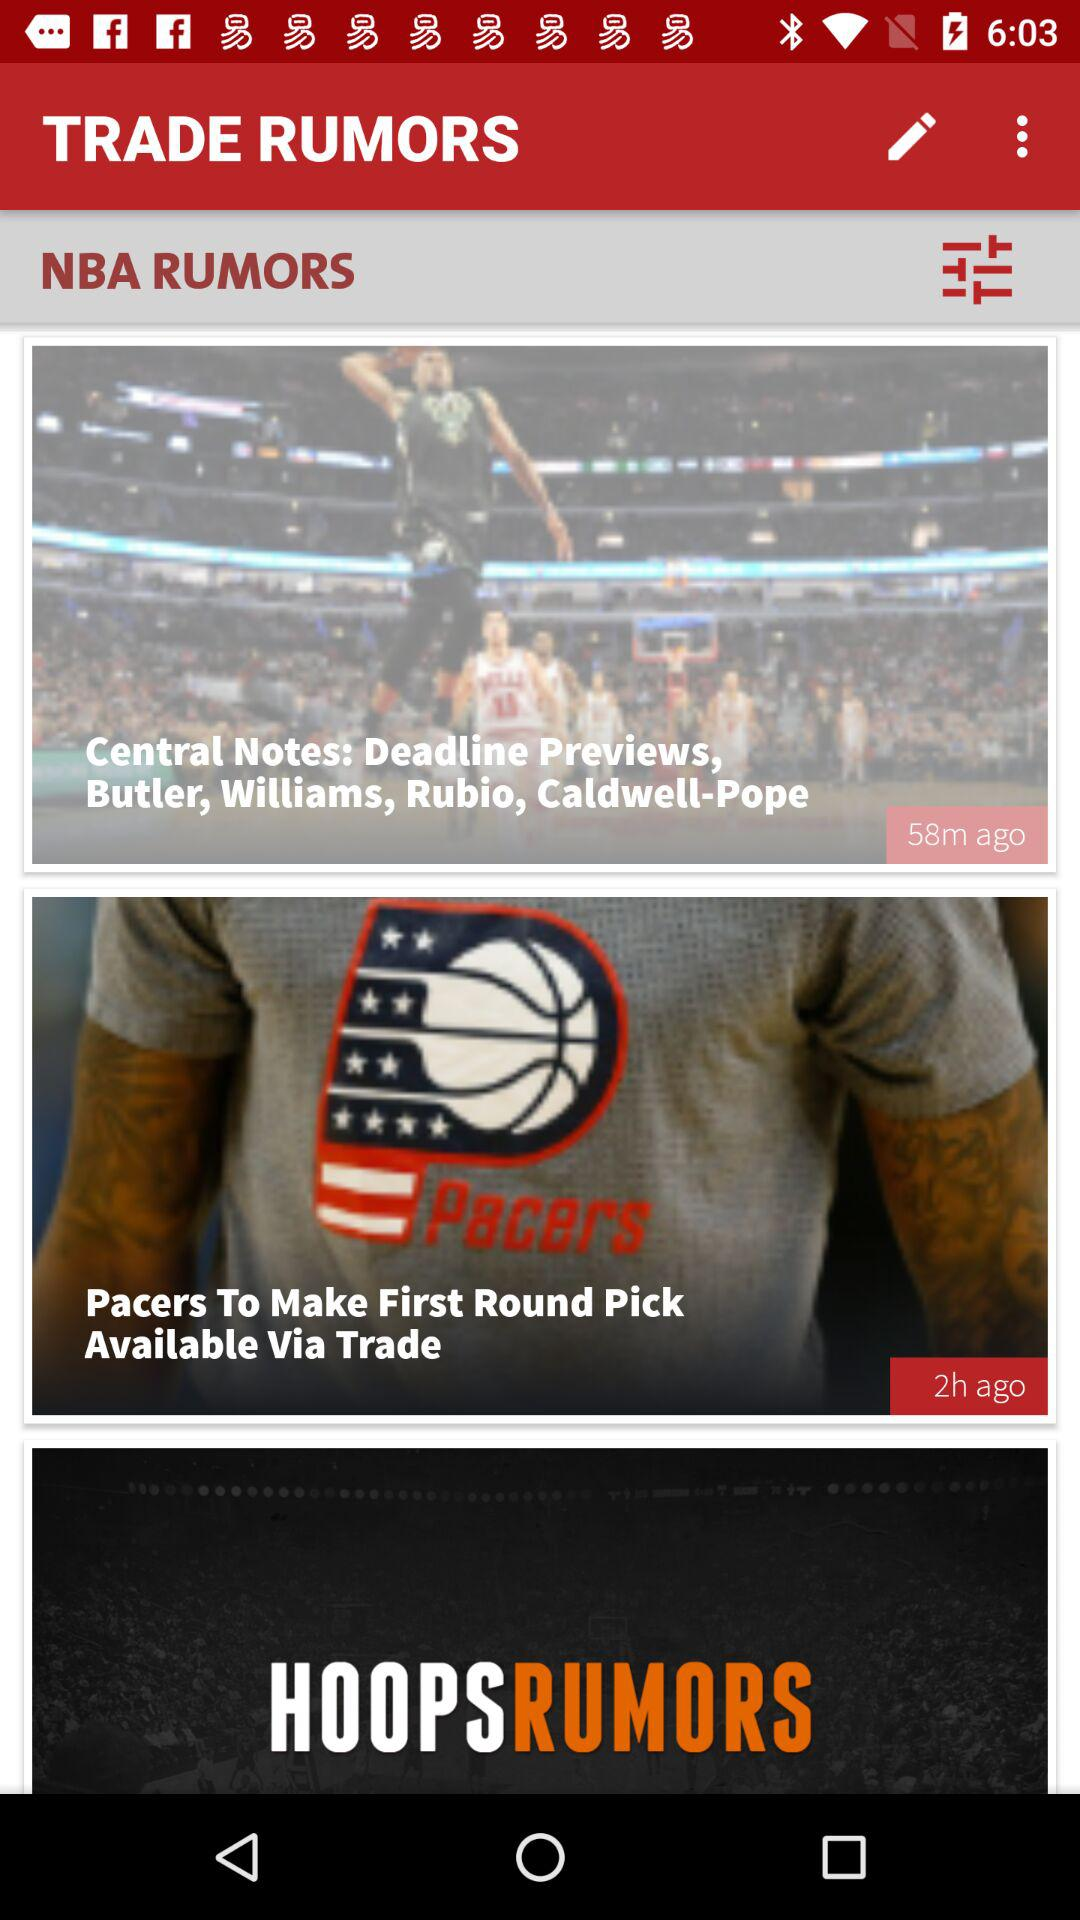How many items have a time stamp?
Answer the question using a single word or phrase. 2 